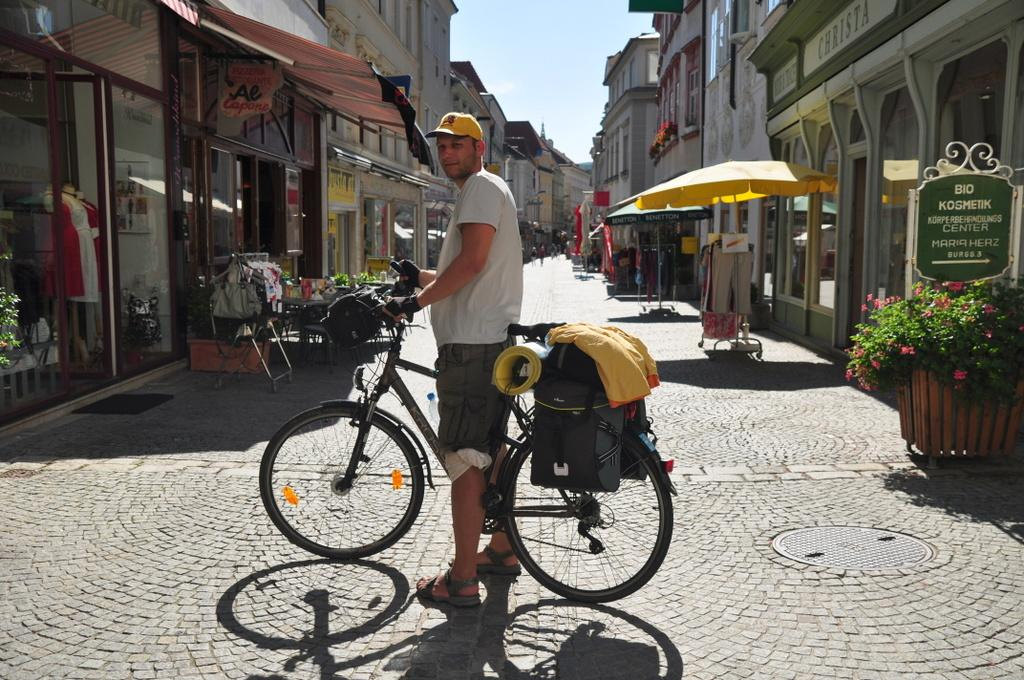Who is present in the image? There is a man in the image. What is the man holding in the image? The man is holding a bicycle. What can be seen in the background of the image? There are plants and houses visible in the image. What objects are present for protection from the rain? There are umbrellas in the image. What type of potato is being blown away by the wind in the image? There is no potato present in the image, and therefore no potato can be blown away by the wind. 